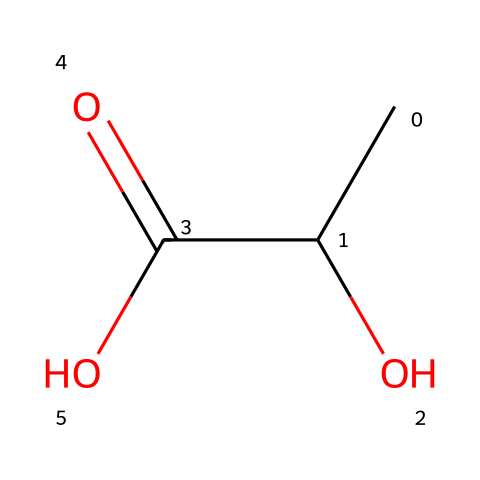What is the name of this chemical? The structure represented by the SMILES CC(O)C(=O)O corresponds to lactic acid. This can be identified by recognizing the specific arrangement of carbon, oxygen, and hydrogen atoms typical of lactic acid.
Answer: lactic acid How many carbon atoms are in lactic acid? Analyzing the SMILES representation, there are two carbon atoms (C) evident in the structure, as "C(C)(C)" indicates the presence of carbon atoms.
Answer: two What functional groups are present in lactic acid? The chemical structure reveals the presence of a hydroxyl group (-OH) and a carboxyl group (-COOH). The -OH group indicates the alcohol functionality, while the -COOH group confirms that this is an acid.
Answer: hydroxyl and carboxyl What is the total number of hydrogen atoms in lactic acid? The structure shows that the two carbon atoms are bonded to three hydrogen atoms (one attached to the carbon with -OH, and two with the adjacent carbon). Together with the hydrogen from the carboxyl group, this totals to six hydrogen atoms in the compound.
Answer: six Is lactic acid a strong or weak acid? Lactic acid is classified as a weak acid based on its tendency to partially dissociate in water compared to strong acids, which fully dissociate. This partial dissociation is a characteristic feature of organic acids like lactic acid.
Answer: weak What is the significance of lactic acid during exercise? Lactic acid is produced during anaerobic respiration, a process that occurs when the body requires energy faster than oxygen can be supplied. Its accumulation can lead to muscle fatigue during intense exercise.
Answer: muscle fatigue 